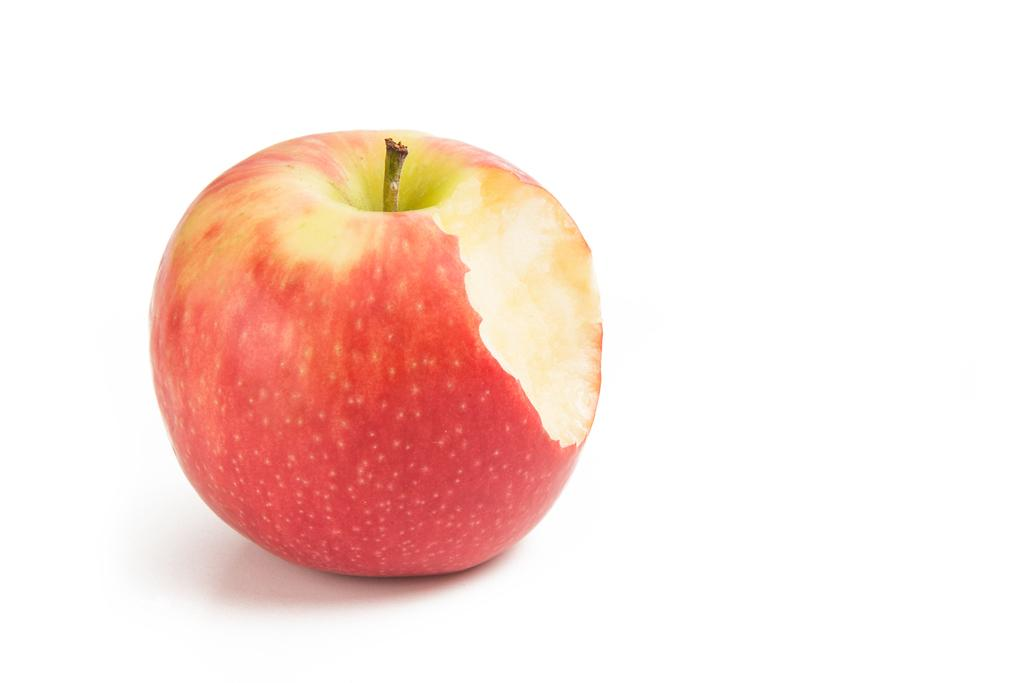What is the main object in the image? There is an apple in the image. How is the apple positioned in the image? The apple is placed on a white platform. What type of spots can be seen on the apple in the image? There are no spots visible on the apple in the image. How does the apple evoke a feeling of disgust in the image? The apple does not evoke a feeling of disgust in the image; it is simply an apple placed on a white platform. 